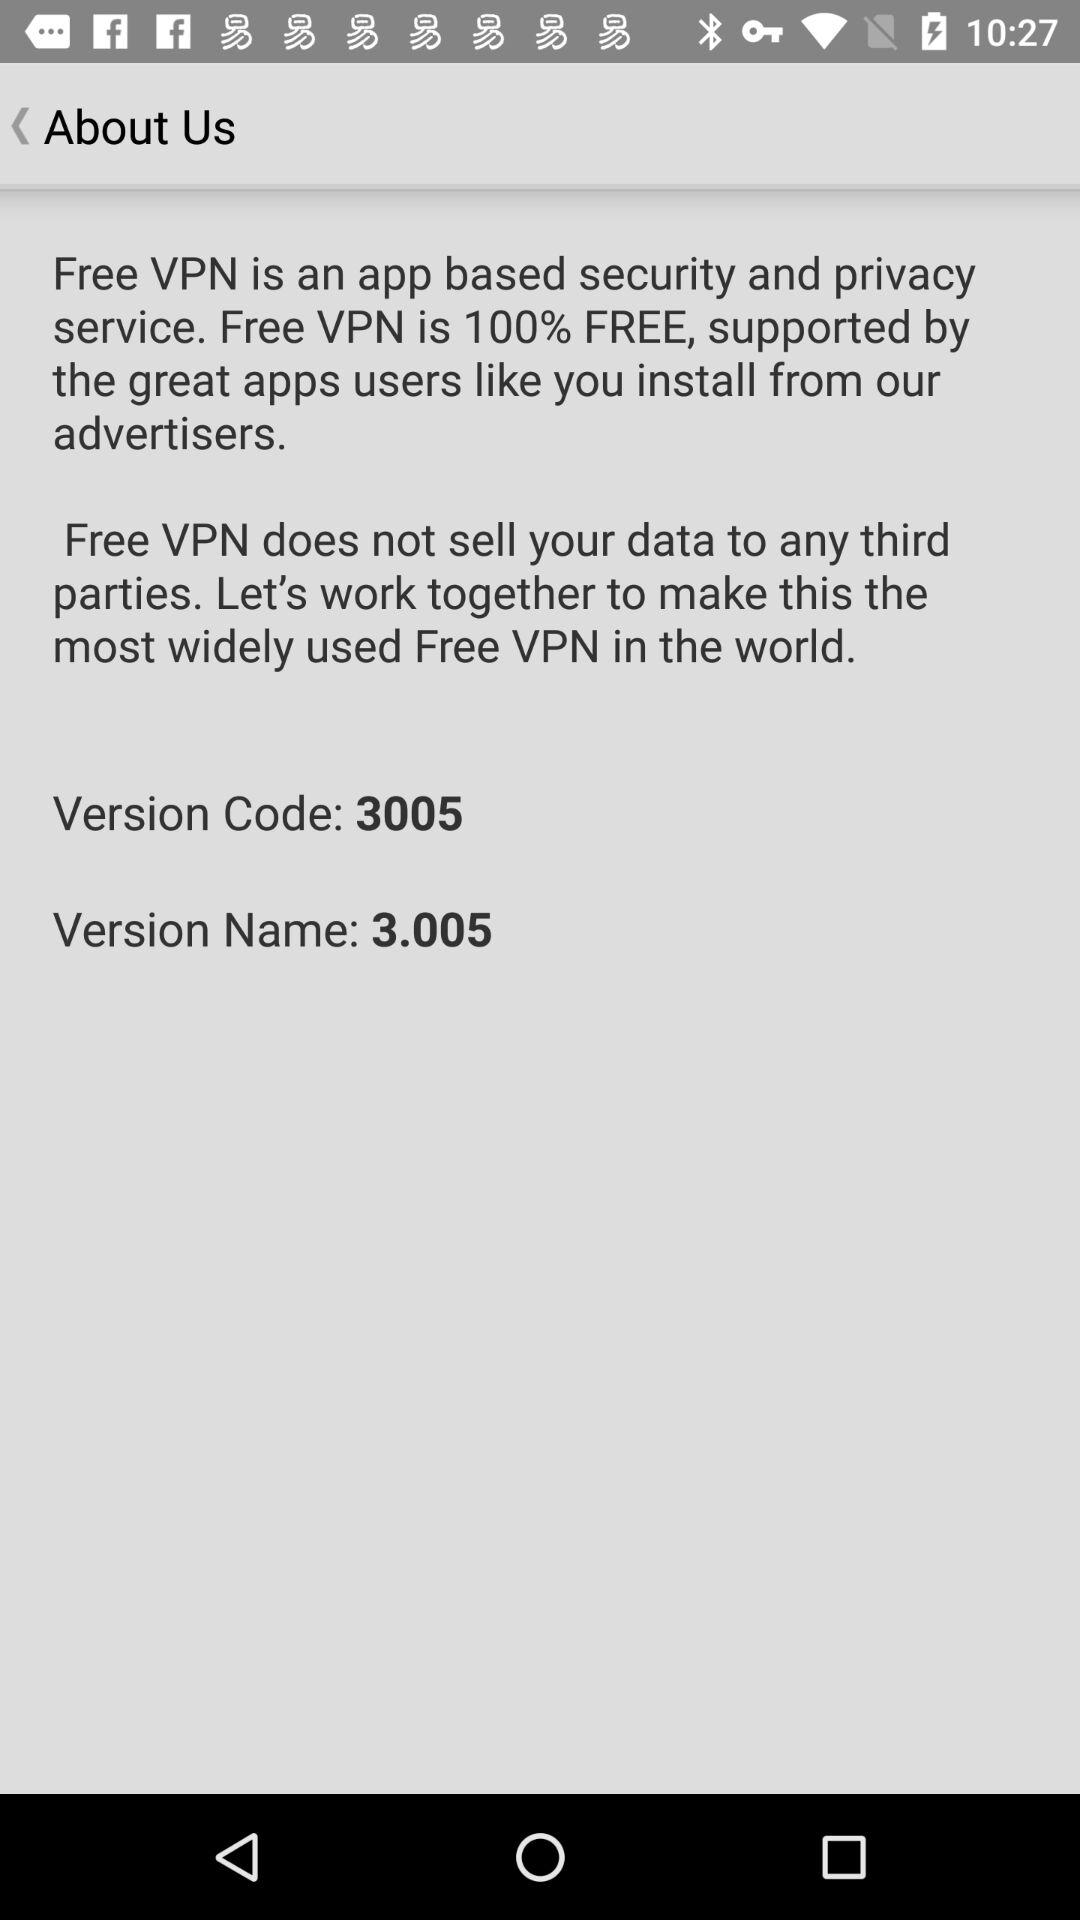What is the version name? The version name is 3.005. 